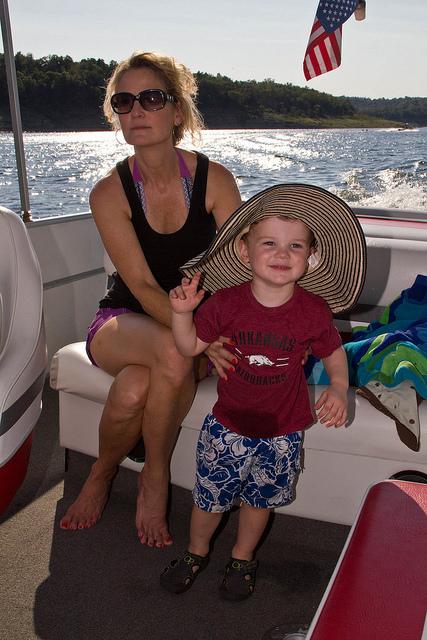Why does the child have a big hat on?
Write a very short answer. Sun protection. What are these people riding in?
Keep it brief. Boat. Should the child be wearing a life vest?
Give a very brief answer. Yes. 